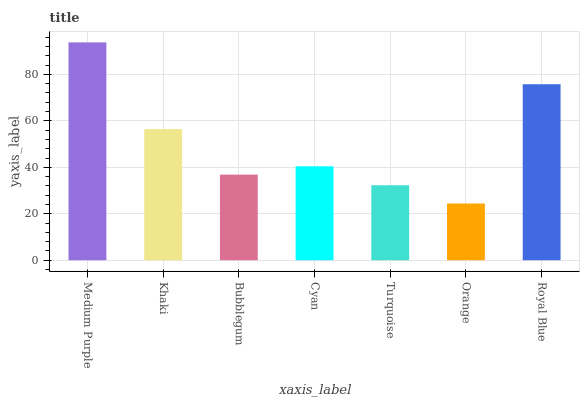Is Khaki the minimum?
Answer yes or no. No. Is Khaki the maximum?
Answer yes or no. No. Is Medium Purple greater than Khaki?
Answer yes or no. Yes. Is Khaki less than Medium Purple?
Answer yes or no. Yes. Is Khaki greater than Medium Purple?
Answer yes or no. No. Is Medium Purple less than Khaki?
Answer yes or no. No. Is Cyan the high median?
Answer yes or no. Yes. Is Cyan the low median?
Answer yes or no. Yes. Is Royal Blue the high median?
Answer yes or no. No. Is Bubblegum the low median?
Answer yes or no. No. 